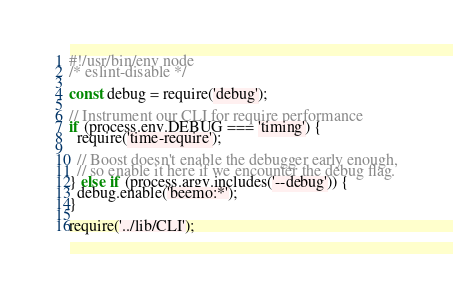<code> <loc_0><loc_0><loc_500><loc_500><_JavaScript_>#!/usr/bin/env node
/* eslint-disable */

const debug = require('debug');

// Instrument our CLI for require performance
if (process.env.DEBUG === 'timing') {
  require('time-require');

  // Boost doesn't enable the debugger early enough,
  // so enable it here if we encounter the debug flag.
} else if (process.argv.includes('--debug')) {
  debug.enable('beemo:*');
}

require('../lib/CLI');
</code> 